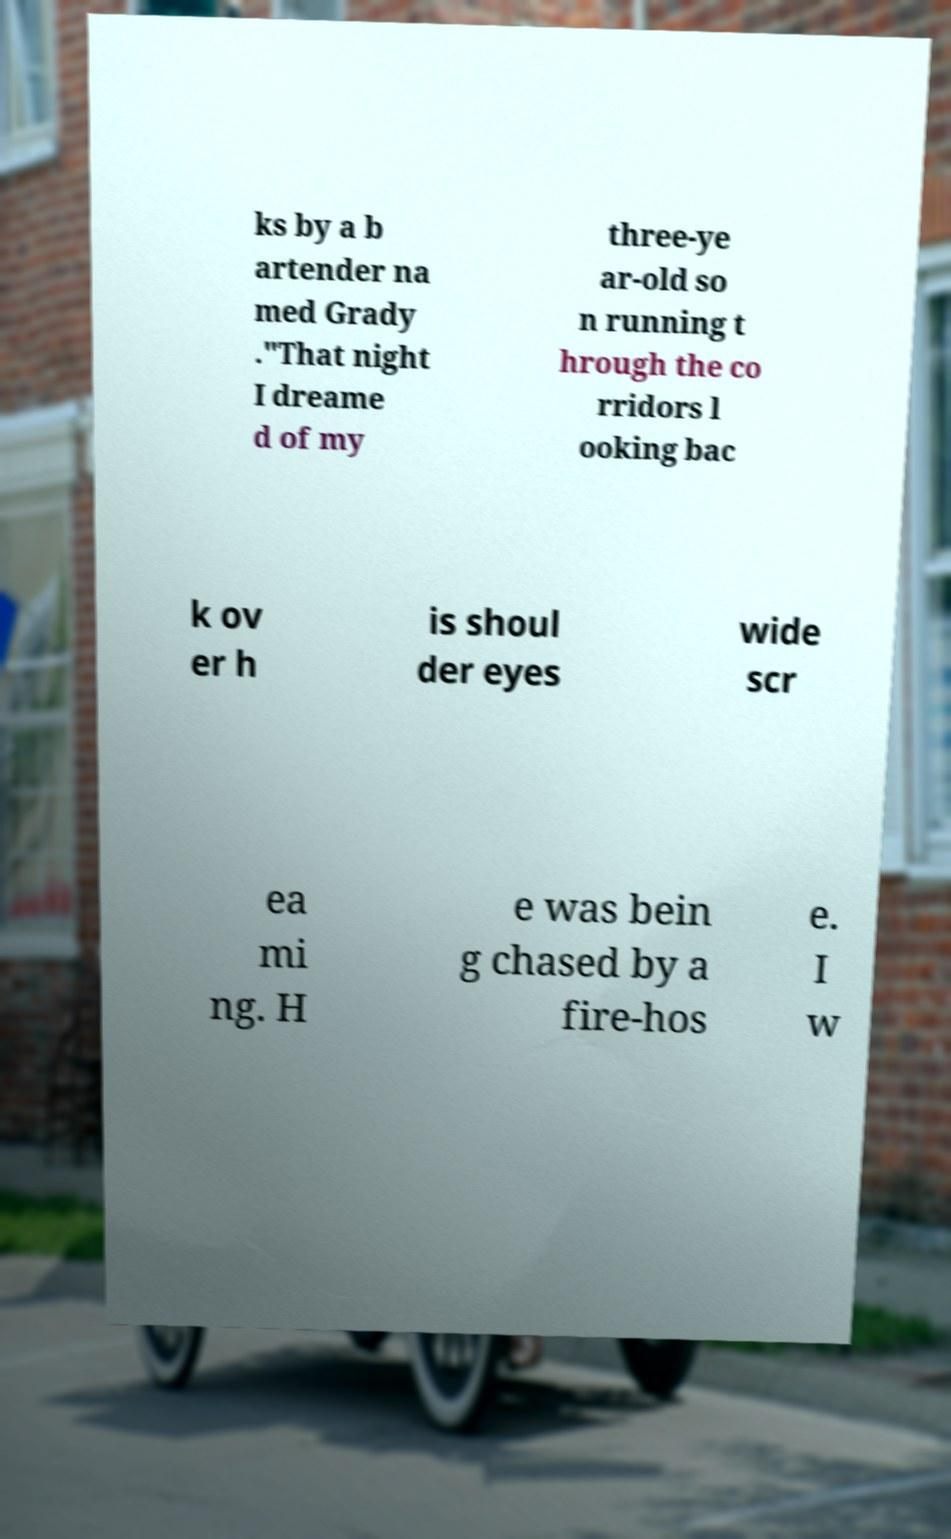Can you read and provide the text displayed in the image?This photo seems to have some interesting text. Can you extract and type it out for me? ks by a b artender na med Grady ."That night I dreame d of my three-ye ar-old so n running t hrough the co rridors l ooking bac k ov er h is shoul der eyes wide scr ea mi ng. H e was bein g chased by a fire-hos e. I w 